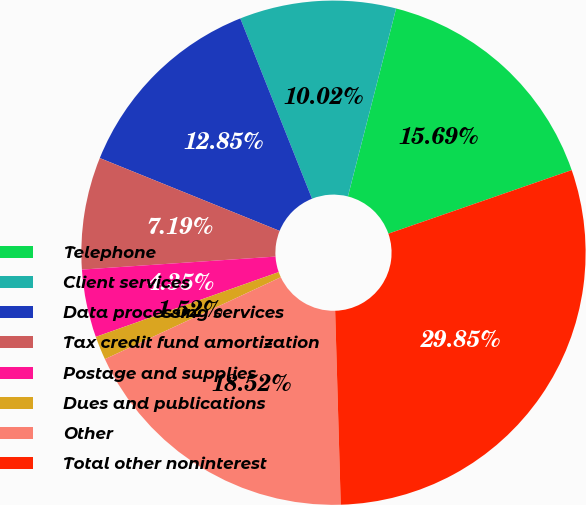Convert chart. <chart><loc_0><loc_0><loc_500><loc_500><pie_chart><fcel>Telephone<fcel>Client services<fcel>Data processing services<fcel>Tax credit fund amortization<fcel>Postage and supplies<fcel>Dues and publications<fcel>Other<fcel>Total other noninterest<nl><fcel>15.69%<fcel>10.02%<fcel>12.85%<fcel>7.19%<fcel>4.35%<fcel>1.52%<fcel>18.52%<fcel>29.85%<nl></chart> 